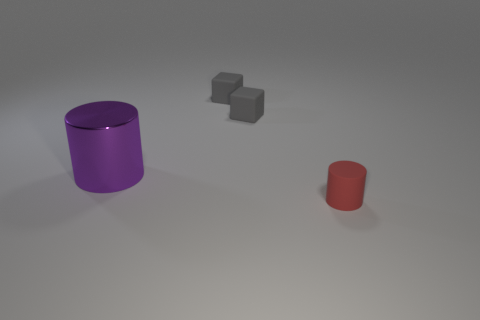What number of other objects are the same material as the big purple thing?
Provide a short and direct response. 0. How many metal things are large purple cylinders or large yellow spheres?
Provide a succinct answer. 1. Are there fewer blue blocks than objects?
Keep it short and to the point. Yes. There is a purple thing; does it have the same size as the cylinder right of the big purple metal thing?
Provide a succinct answer. No. The red object is what size?
Offer a terse response. Small. Are there fewer matte cylinders that are on the right side of the small red thing than cyan rubber spheres?
Keep it short and to the point. No. Is the size of the red matte object the same as the purple metallic object?
Provide a succinct answer. No. Are there any other things that are the same size as the metallic cylinder?
Your response must be concise. No. Are there fewer large objects that are to the right of the big purple object than gray cubes behind the tiny red cylinder?
Offer a terse response. Yes. How many things are behind the tiny red rubber cylinder and right of the purple metallic cylinder?
Provide a short and direct response. 2. 